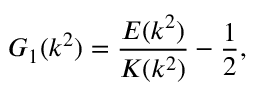Convert formula to latex. <formula><loc_0><loc_0><loc_500><loc_500>G _ { 1 } ( k ^ { 2 } ) = \frac { E ( k ^ { 2 } ) } { K ( k ^ { 2 } ) } - \frac { 1 } { 2 } ,</formula> 